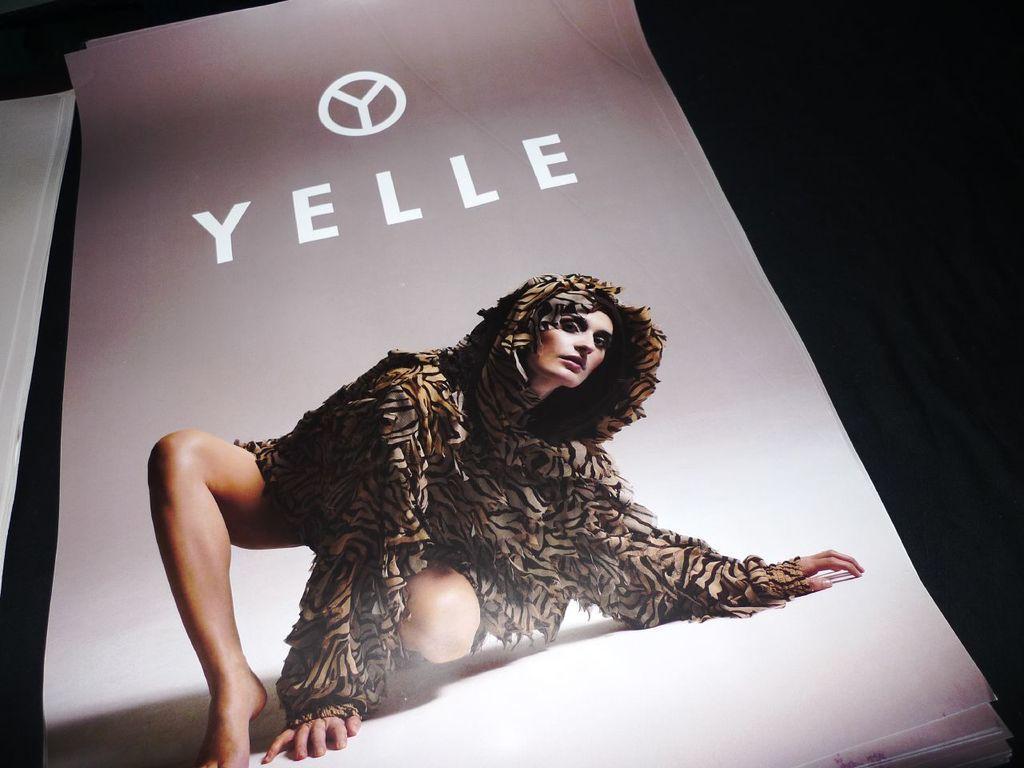Can you describe this image briefly? In this picture I can see a person, logo and a word on the paper, there are papers, and there is dark background. 